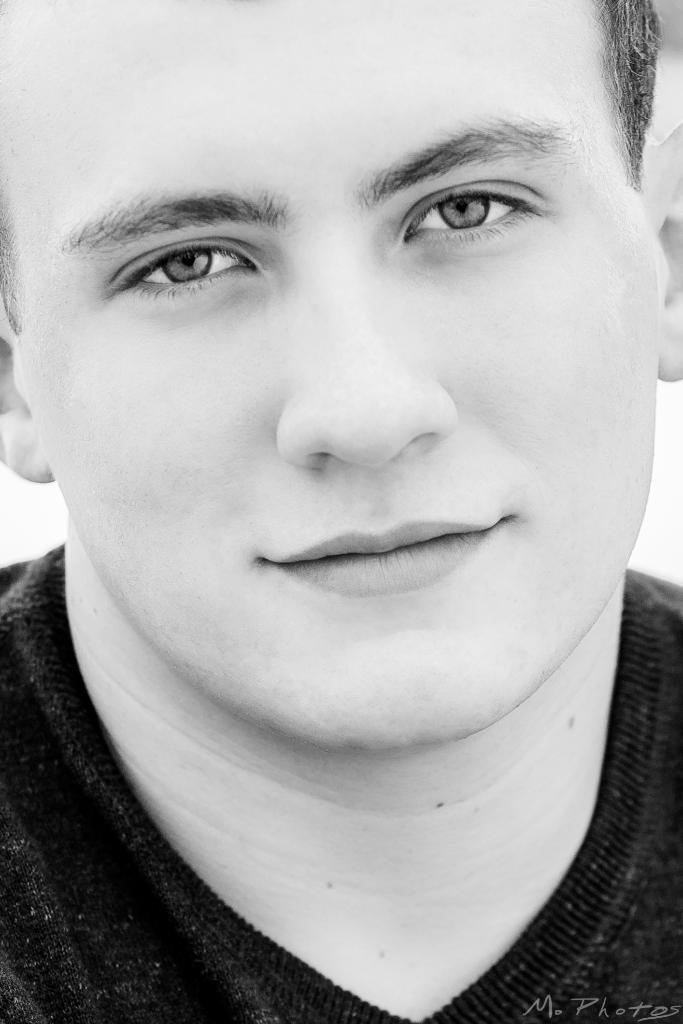What type of picture is in the image? The image contains a black and white picture. What is the subject of the picture? The picture depicts a person. Where is the chair located in the image? There is no chair present in the image. What type of steam can be seen coming from the person in the image? There is no steam present in the image. 